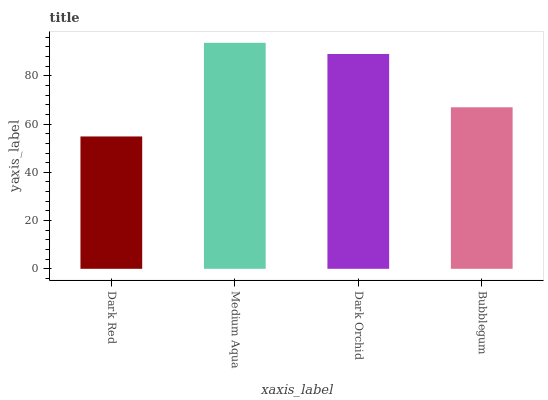Is Dark Red the minimum?
Answer yes or no. Yes. Is Medium Aqua the maximum?
Answer yes or no. Yes. Is Dark Orchid the minimum?
Answer yes or no. No. Is Dark Orchid the maximum?
Answer yes or no. No. Is Medium Aqua greater than Dark Orchid?
Answer yes or no. Yes. Is Dark Orchid less than Medium Aqua?
Answer yes or no. Yes. Is Dark Orchid greater than Medium Aqua?
Answer yes or no. No. Is Medium Aqua less than Dark Orchid?
Answer yes or no. No. Is Dark Orchid the high median?
Answer yes or no. Yes. Is Bubblegum the low median?
Answer yes or no. Yes. Is Bubblegum the high median?
Answer yes or no. No. Is Dark Red the low median?
Answer yes or no. No. 